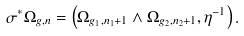Convert formula to latex. <formula><loc_0><loc_0><loc_500><loc_500>\sigma ^ { * } \Omega _ { g , n } = \left ( \Omega _ { g _ { 1 } , n _ { 1 } + 1 } \wedge \Omega _ { g _ { 2 } , n _ { 2 } + 1 } , \eta ^ { - 1 } \right ) .</formula> 